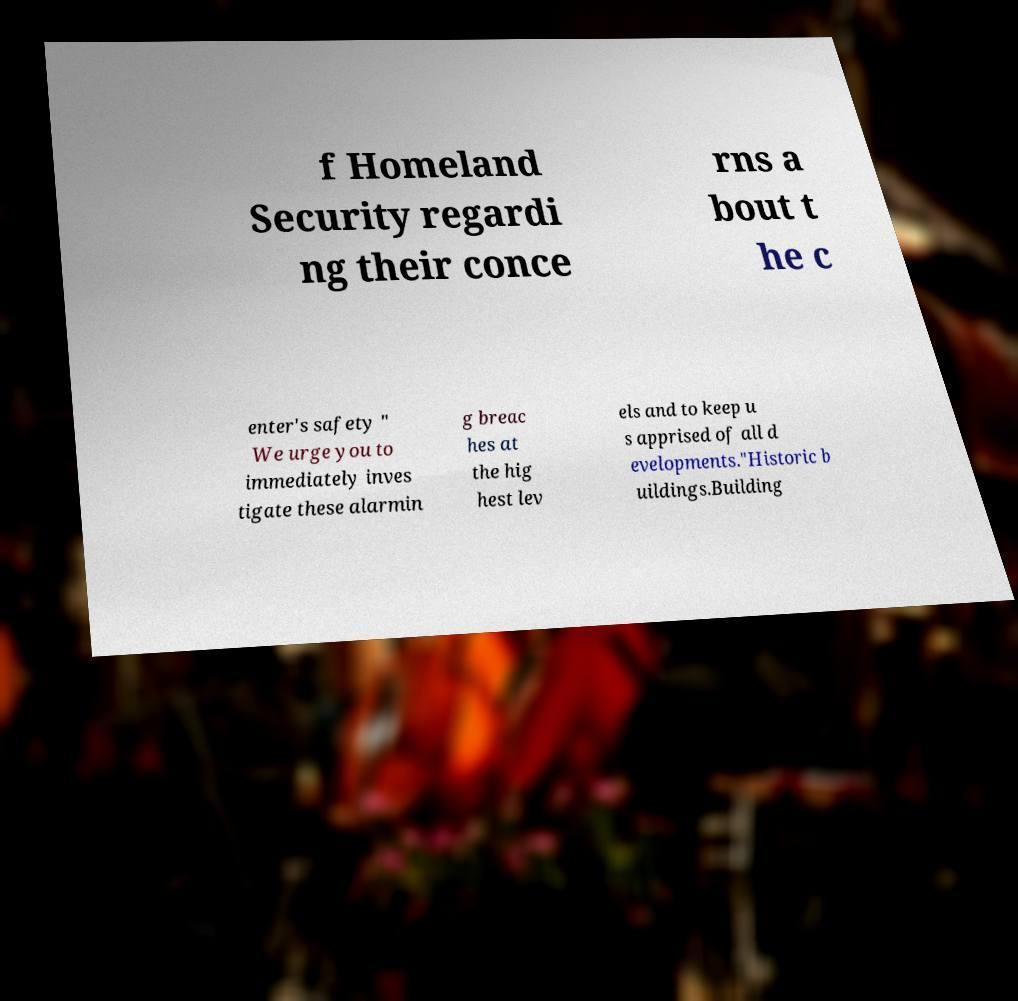Can you accurately transcribe the text from the provided image for me? f Homeland Security regardi ng their conce rns a bout t he c enter's safety " We urge you to immediately inves tigate these alarmin g breac hes at the hig hest lev els and to keep u s apprised of all d evelopments."Historic b uildings.Building 